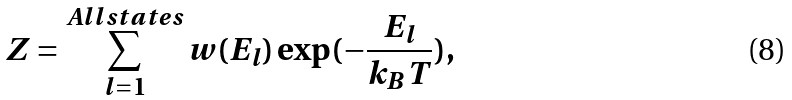<formula> <loc_0><loc_0><loc_500><loc_500>Z = \sum _ { l = 1 } ^ { A l l s t a t e s } w ( E _ { l } ) \exp ( - \frac { E _ { l } } { k _ { B } T } ) ,</formula> 